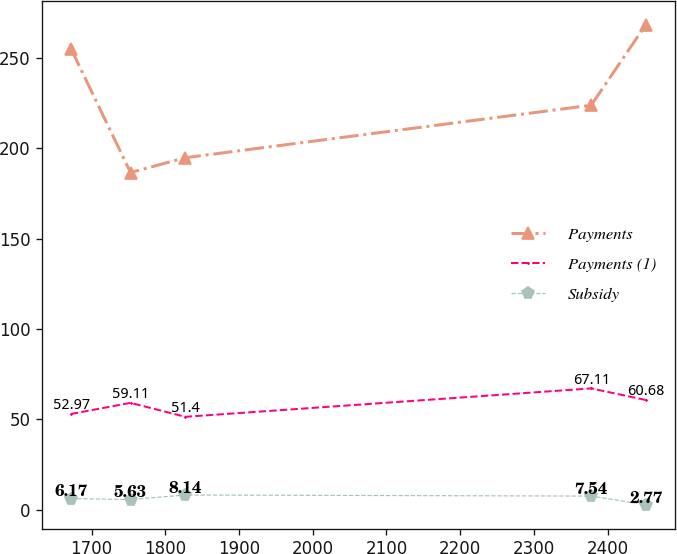<chart> <loc_0><loc_0><loc_500><loc_500><line_chart><ecel><fcel>Payments<fcel>Payments (1)<fcel>Subsidy<nl><fcel>1671.98<fcel>255.11<fcel>52.97<fcel>6.17<nl><fcel>1752.89<fcel>186.53<fcel>59.11<fcel>5.63<nl><fcel>1827.17<fcel>194.72<fcel>51.4<fcel>8.14<nl><fcel>2377.73<fcel>223.75<fcel>67.11<fcel>7.54<nl><fcel>2452.01<fcel>268.4<fcel>60.68<fcel>2.77<nl></chart> 